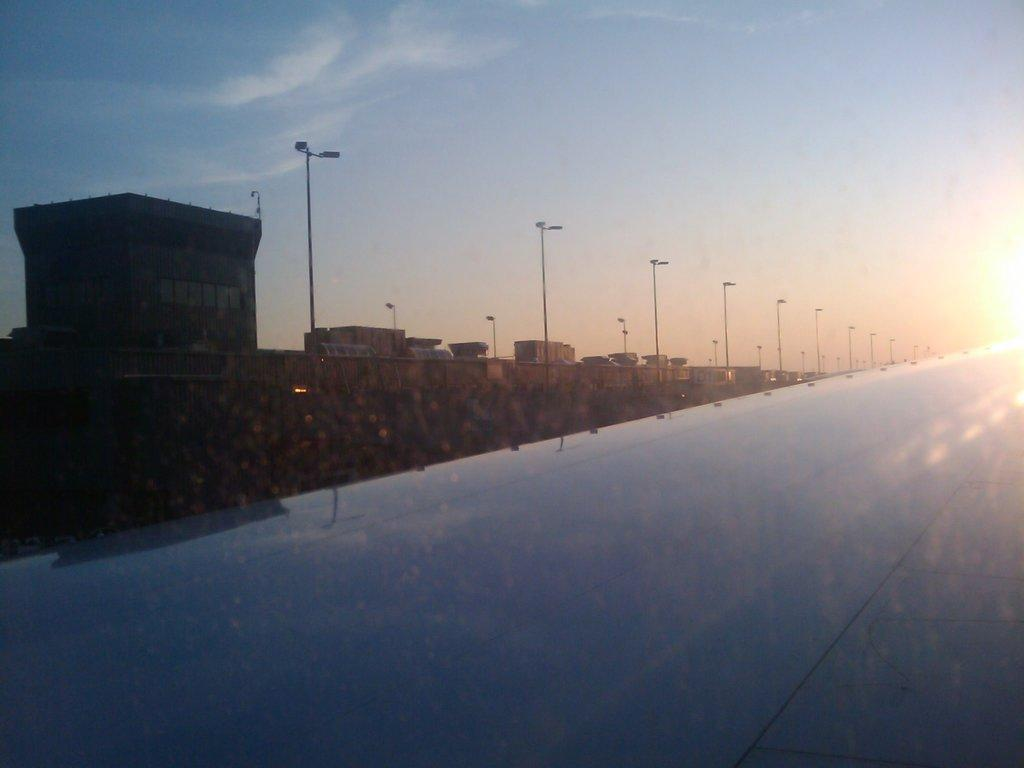What is the main feature of the image? There is a road in the image. What else can be seen along the road? There are poles with lights in the image. What structures are visible on the left side of the image? There are buildings on the left side of the image. How would you describe the weather in the image? The sky is clear and sunny in the image. Can you see a record player in the image? There is no record player present in the image. What type of stick can be seen in the image? There is no stick visible in the image. 